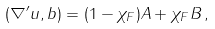Convert formula to latex. <formula><loc_0><loc_0><loc_500><loc_500>( \nabla ^ { \prime } u , b ) = ( 1 - \chi _ { F } ) A + \chi _ { F } B \, ,</formula> 